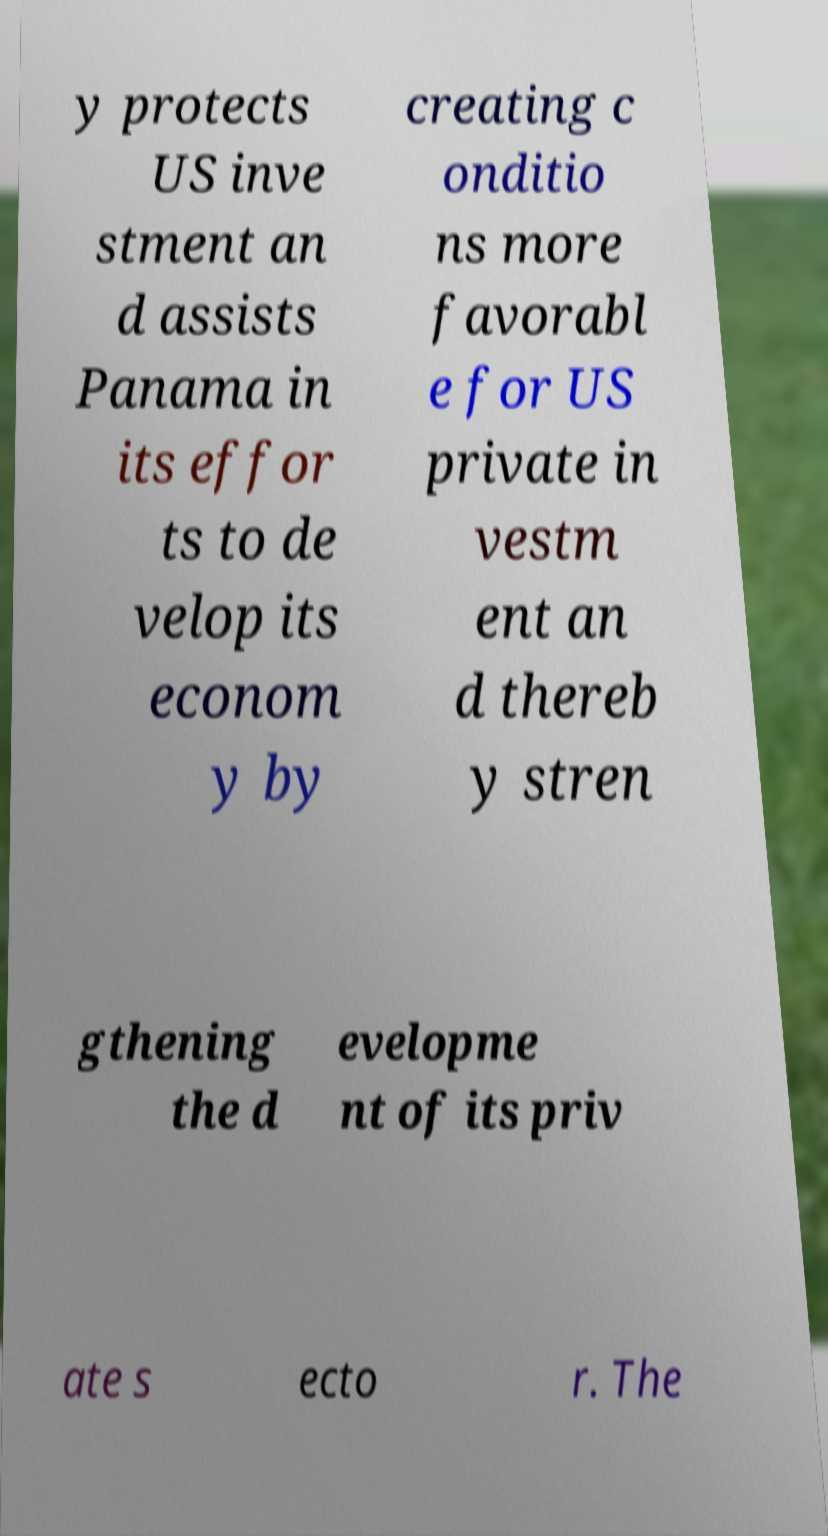Can you read and provide the text displayed in the image?This photo seems to have some interesting text. Can you extract and type it out for me? y protects US inve stment an d assists Panama in its effor ts to de velop its econom y by creating c onditio ns more favorabl e for US private in vestm ent an d thereb y stren gthening the d evelopme nt of its priv ate s ecto r. The 